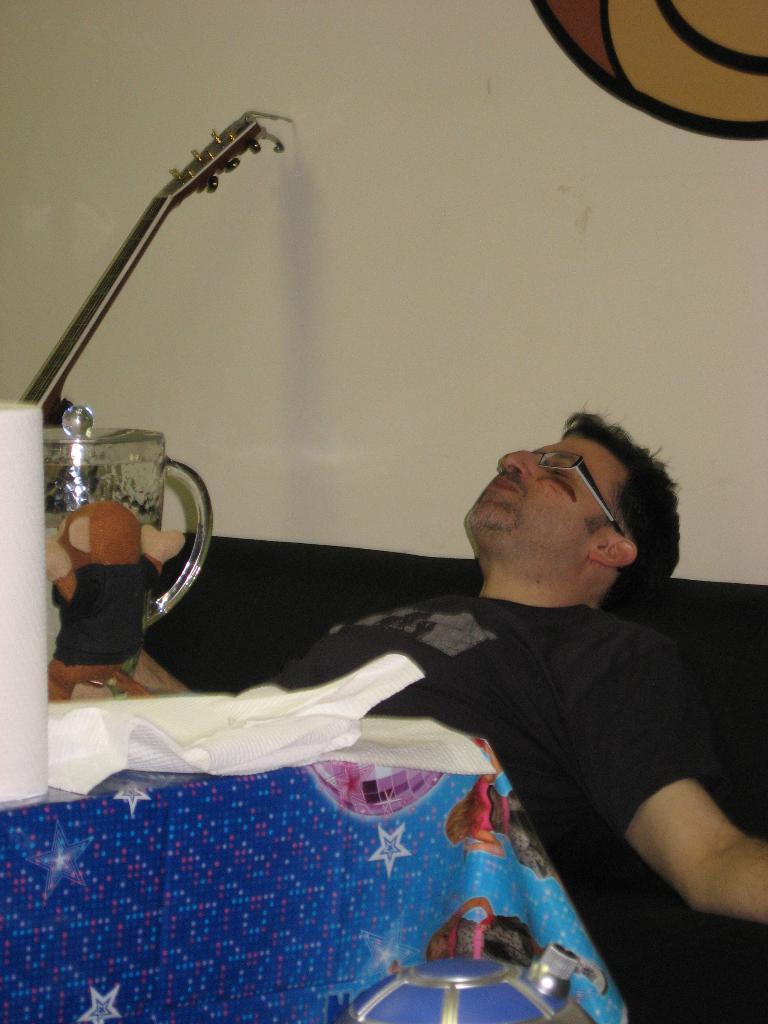In one or two sentences, can you explain what this image depicts? Here I can see a man wearing black color t-shirt and laying on the sofa. In front of him I can see a table which is covered with a blue color cloth. On the table, I can see a jar, guitar and some more objects. In the background, I can see the wall. 